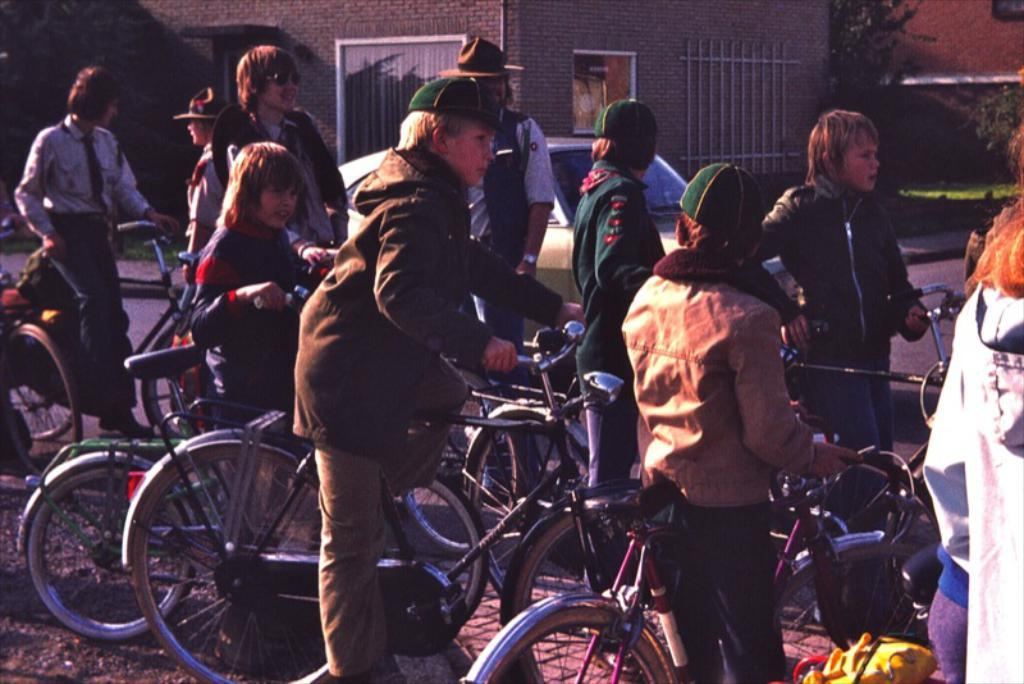Where is the setting of the image? The image is outside a road. What can be seen in the image? There are kids in the image. What are some of the kids doing? Some of the kids are holding bicycles. What are the kids wearing on their heads? Some of the kids are wearing green caps. What type of clothing are the kids wearing? All of the kids are wearing winter clothes. What can be seen in the background of the image? There is a building and trees in the background of the image. What type of meat is being cooked on the stove in the image? There is no stove or meat present in the image. 